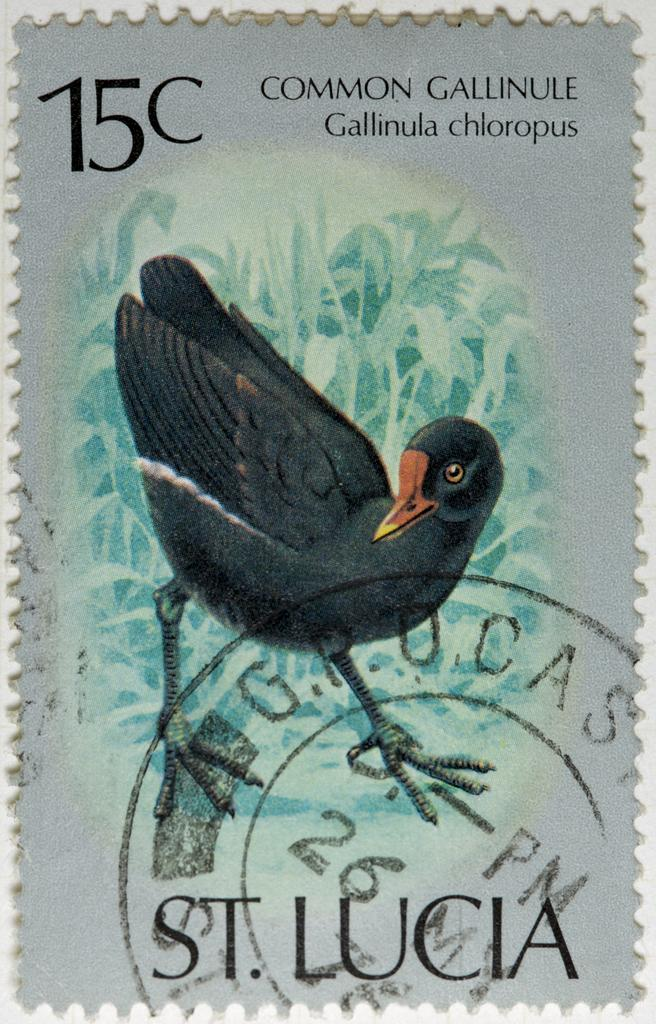What is the main object in the image? There is a stamp in the image. What can be seen on the stamp? The stamp has some script on it and a bird depicted on it. What type of cannon is shown in the background of the image? There is no cannon present in the image; it only features a stamp with a bird and script. What color is the collar on the bird depicted on the stamp? The image does not show a collar on the bird depicted on the stamp, nor does it provide any information about the bird's color. 